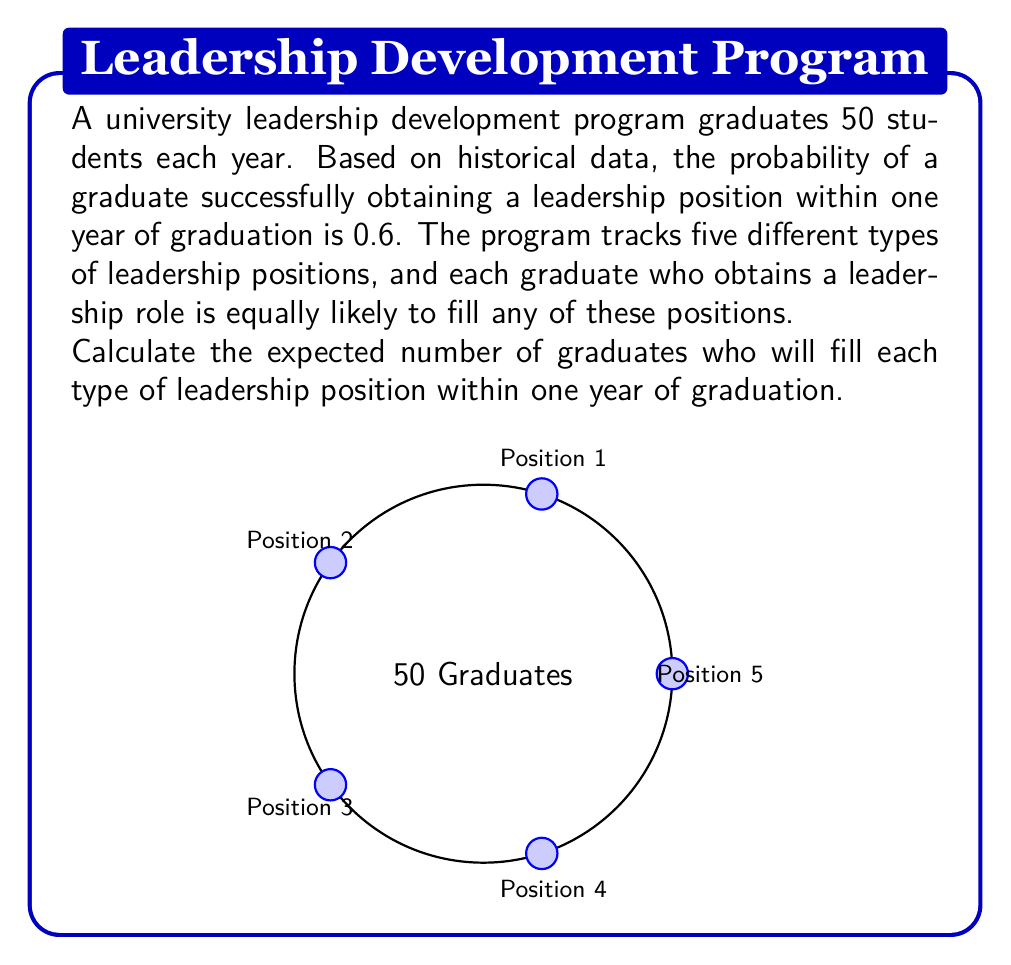Give your solution to this math problem. Let's approach this step-by-step:

1) First, we need to calculate the expected number of graduates who will obtain any leadership position:

   $$ E(\text{total leadership positions}) = 50 \times 0.6 = 30 $$

2) Now, we know that these 30 expected successful graduates are equally likely to fill any of the five types of leadership positions.

3) To find the expected number for each type of position, we divide the total by 5:

   $$ E(\text{each type of position}) = \frac{30}{5} = 6 $$

4) We can verify this mathematically using the properties of expected value:

   Let $X_i$ be the number of graduates filling position type $i$ (where $i = 1, 2, 3, 4, 5$).

   Each graduate has a probability of $0.6 \times \frac{1}{5} = 0.12$ of filling any specific position type.

   For each graduate, $X_i$ follows a Bernoulli distribution with $p = 0.12$.

   $$ E(X_i) = 50 \times 0.12 = 6 $$

5) This confirms our earlier calculation.
Answer: 6 graduates 